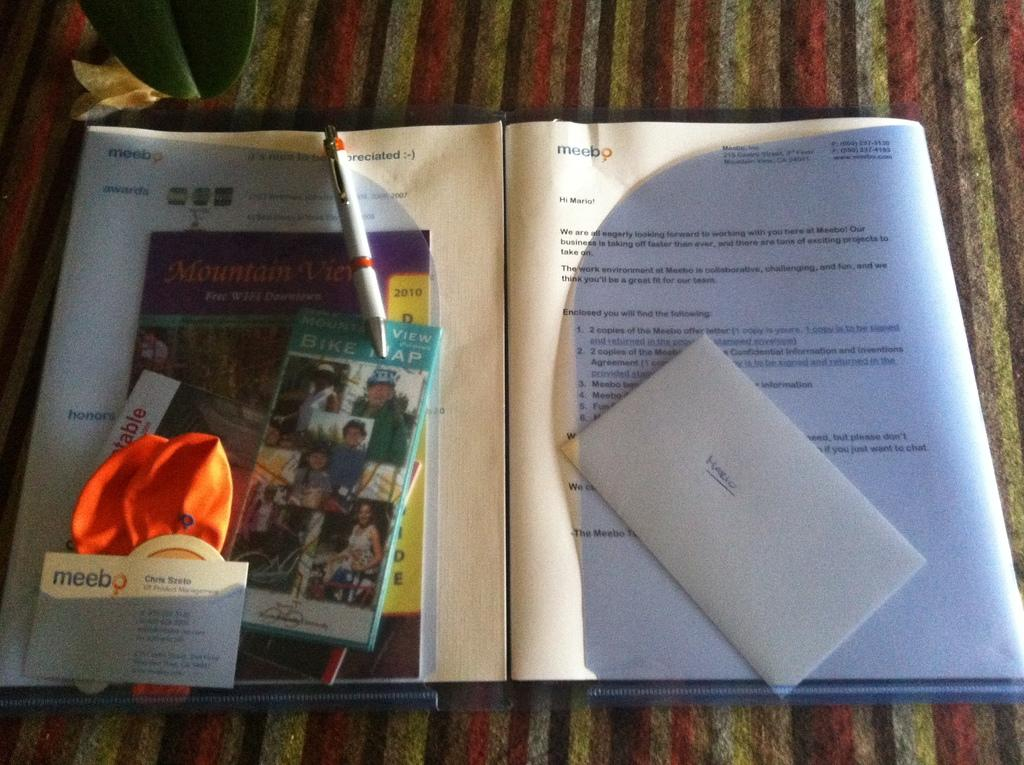<image>
Provide a brief description of the given image. On the right side of an open folder, there is an envelope with the name Mario on it. 